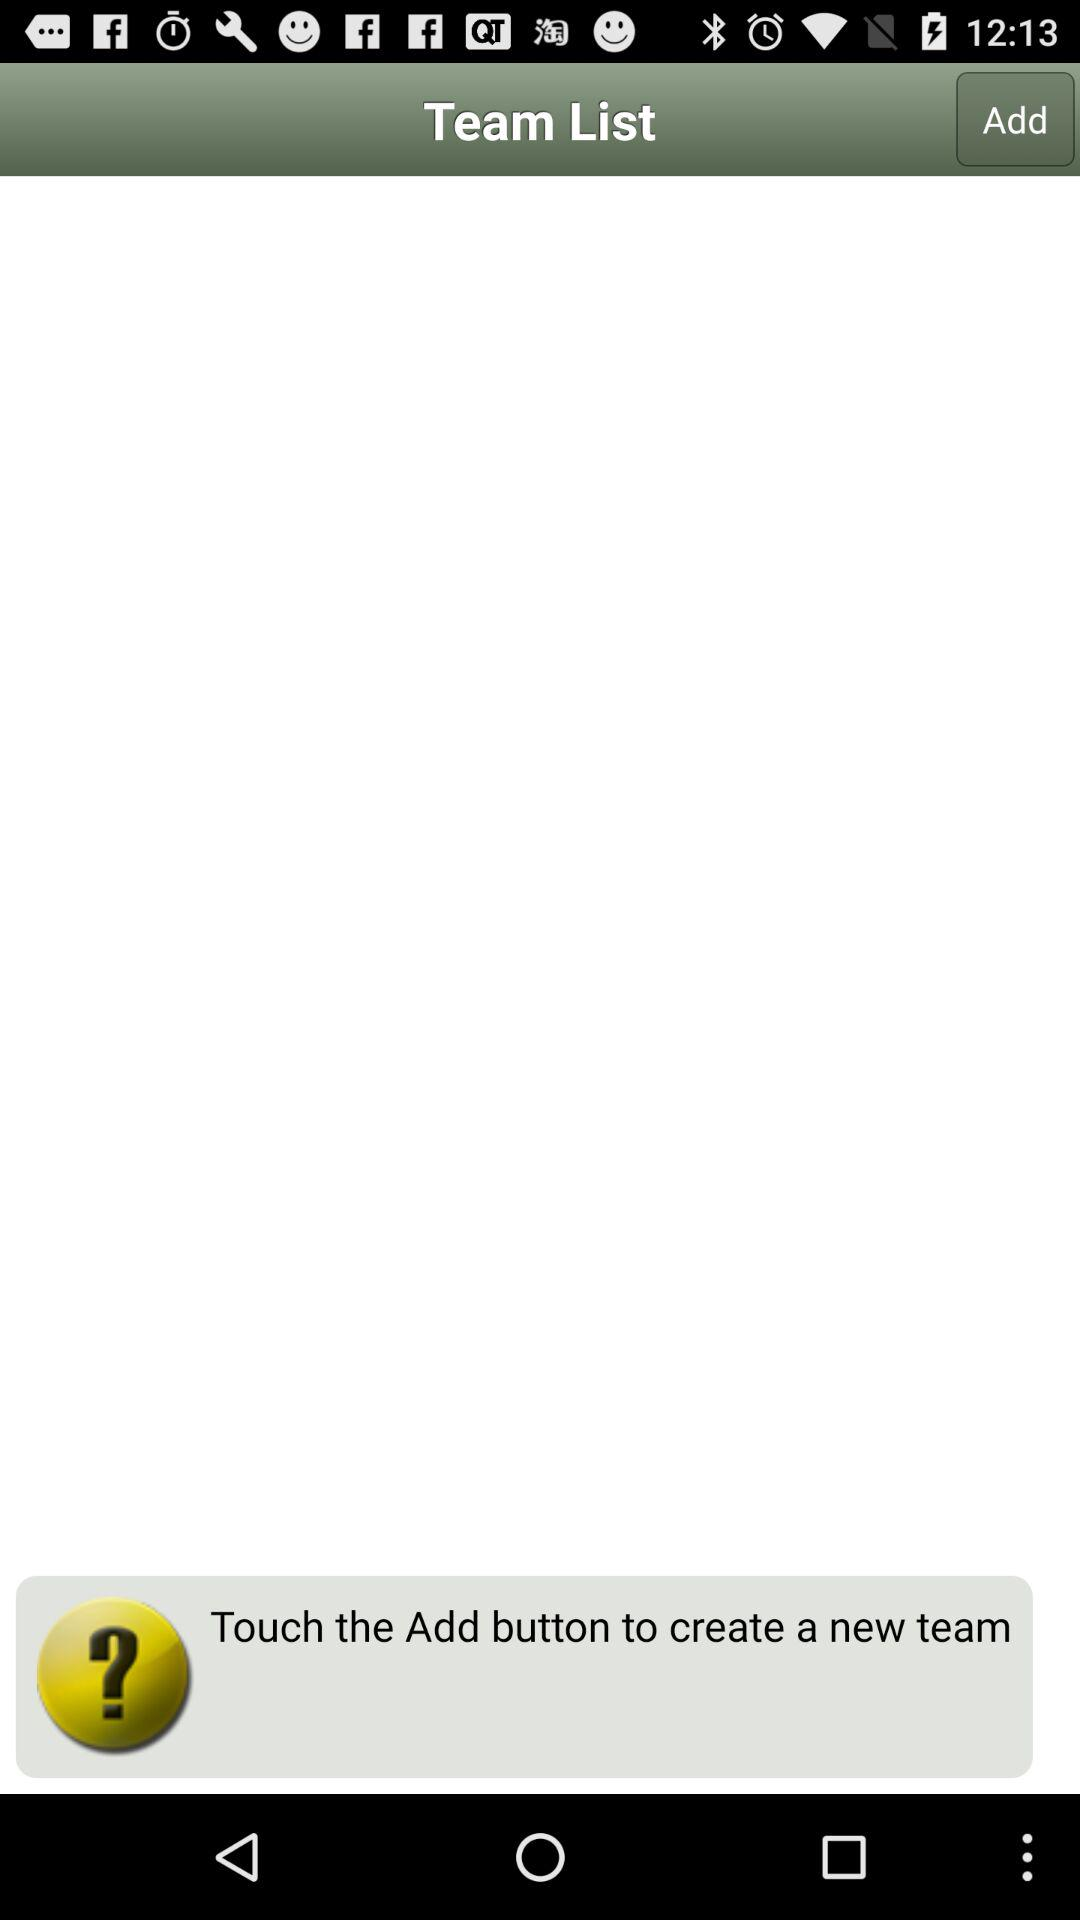What is the application name?
When the provided information is insufficient, respond with <no answer>. <no answer> 